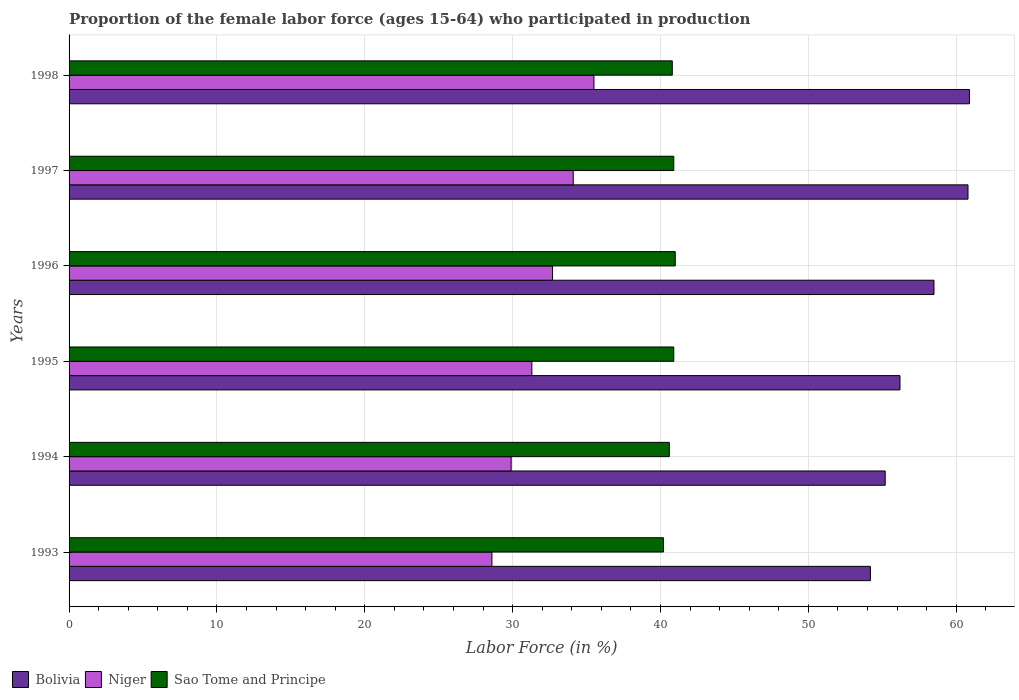Are the number of bars per tick equal to the number of legend labels?
Ensure brevity in your answer.  Yes. Are the number of bars on each tick of the Y-axis equal?
Provide a short and direct response. Yes. How many bars are there on the 2nd tick from the top?
Provide a short and direct response. 3. How many bars are there on the 4th tick from the bottom?
Give a very brief answer. 3. What is the label of the 1st group of bars from the top?
Make the answer very short. 1998. What is the proportion of the female labor force who participated in production in Sao Tome and Principe in 1998?
Make the answer very short. 40.8. Across all years, what is the maximum proportion of the female labor force who participated in production in Niger?
Offer a terse response. 35.5. Across all years, what is the minimum proportion of the female labor force who participated in production in Niger?
Provide a succinct answer. 28.6. In which year was the proportion of the female labor force who participated in production in Niger maximum?
Provide a short and direct response. 1998. What is the total proportion of the female labor force who participated in production in Sao Tome and Principe in the graph?
Your answer should be very brief. 244.4. What is the difference between the proportion of the female labor force who participated in production in Sao Tome and Principe in 1994 and that in 1996?
Keep it short and to the point. -0.4. What is the difference between the proportion of the female labor force who participated in production in Niger in 1997 and the proportion of the female labor force who participated in production in Sao Tome and Principe in 1998?
Ensure brevity in your answer.  -6.7. What is the average proportion of the female labor force who participated in production in Niger per year?
Offer a terse response. 32.02. In the year 1996, what is the difference between the proportion of the female labor force who participated in production in Sao Tome and Principe and proportion of the female labor force who participated in production in Niger?
Offer a very short reply. 8.3. What is the ratio of the proportion of the female labor force who participated in production in Sao Tome and Principe in 1993 to that in 1995?
Provide a short and direct response. 0.98. Is the difference between the proportion of the female labor force who participated in production in Sao Tome and Principe in 1993 and 1997 greater than the difference between the proportion of the female labor force who participated in production in Niger in 1993 and 1997?
Your answer should be compact. Yes. What is the difference between the highest and the second highest proportion of the female labor force who participated in production in Sao Tome and Principe?
Keep it short and to the point. 0.1. What is the difference between the highest and the lowest proportion of the female labor force who participated in production in Sao Tome and Principe?
Provide a short and direct response. 0.8. Is the sum of the proportion of the female labor force who participated in production in Sao Tome and Principe in 1994 and 1995 greater than the maximum proportion of the female labor force who participated in production in Niger across all years?
Your response must be concise. Yes. What does the 3rd bar from the bottom in 1996 represents?
Keep it short and to the point. Sao Tome and Principe. Is it the case that in every year, the sum of the proportion of the female labor force who participated in production in Sao Tome and Principe and proportion of the female labor force who participated in production in Niger is greater than the proportion of the female labor force who participated in production in Bolivia?
Your answer should be compact. Yes. How many years are there in the graph?
Your answer should be very brief. 6. What is the difference between two consecutive major ticks on the X-axis?
Ensure brevity in your answer.  10. Does the graph contain any zero values?
Your answer should be very brief. No. Does the graph contain grids?
Keep it short and to the point. Yes. How many legend labels are there?
Ensure brevity in your answer.  3. What is the title of the graph?
Keep it short and to the point. Proportion of the female labor force (ages 15-64) who participated in production. What is the label or title of the X-axis?
Keep it short and to the point. Labor Force (in %). What is the Labor Force (in %) in Bolivia in 1993?
Provide a short and direct response. 54.2. What is the Labor Force (in %) in Niger in 1993?
Keep it short and to the point. 28.6. What is the Labor Force (in %) of Sao Tome and Principe in 1993?
Give a very brief answer. 40.2. What is the Labor Force (in %) of Bolivia in 1994?
Your answer should be compact. 55.2. What is the Labor Force (in %) of Niger in 1994?
Give a very brief answer. 29.9. What is the Labor Force (in %) of Sao Tome and Principe in 1994?
Ensure brevity in your answer.  40.6. What is the Labor Force (in %) in Bolivia in 1995?
Ensure brevity in your answer.  56.2. What is the Labor Force (in %) of Niger in 1995?
Ensure brevity in your answer.  31.3. What is the Labor Force (in %) of Sao Tome and Principe in 1995?
Provide a succinct answer. 40.9. What is the Labor Force (in %) of Bolivia in 1996?
Offer a very short reply. 58.5. What is the Labor Force (in %) of Niger in 1996?
Provide a succinct answer. 32.7. What is the Labor Force (in %) in Sao Tome and Principe in 1996?
Provide a succinct answer. 41. What is the Labor Force (in %) in Bolivia in 1997?
Your answer should be very brief. 60.8. What is the Labor Force (in %) in Niger in 1997?
Make the answer very short. 34.1. What is the Labor Force (in %) of Sao Tome and Principe in 1997?
Ensure brevity in your answer.  40.9. What is the Labor Force (in %) of Bolivia in 1998?
Your answer should be very brief. 60.9. What is the Labor Force (in %) of Niger in 1998?
Give a very brief answer. 35.5. What is the Labor Force (in %) in Sao Tome and Principe in 1998?
Keep it short and to the point. 40.8. Across all years, what is the maximum Labor Force (in %) in Bolivia?
Make the answer very short. 60.9. Across all years, what is the maximum Labor Force (in %) of Niger?
Your answer should be very brief. 35.5. Across all years, what is the minimum Labor Force (in %) in Bolivia?
Keep it short and to the point. 54.2. Across all years, what is the minimum Labor Force (in %) in Niger?
Your response must be concise. 28.6. Across all years, what is the minimum Labor Force (in %) of Sao Tome and Principe?
Offer a very short reply. 40.2. What is the total Labor Force (in %) in Bolivia in the graph?
Offer a terse response. 345.8. What is the total Labor Force (in %) of Niger in the graph?
Your answer should be very brief. 192.1. What is the total Labor Force (in %) in Sao Tome and Principe in the graph?
Make the answer very short. 244.4. What is the difference between the Labor Force (in %) in Niger in 1993 and that in 1994?
Your answer should be compact. -1.3. What is the difference between the Labor Force (in %) of Bolivia in 1993 and that in 1995?
Provide a short and direct response. -2. What is the difference between the Labor Force (in %) of Sao Tome and Principe in 1993 and that in 1995?
Your response must be concise. -0.7. What is the difference between the Labor Force (in %) of Bolivia in 1993 and that in 1996?
Provide a short and direct response. -4.3. What is the difference between the Labor Force (in %) of Niger in 1993 and that in 1996?
Ensure brevity in your answer.  -4.1. What is the difference between the Labor Force (in %) of Sao Tome and Principe in 1993 and that in 1996?
Your response must be concise. -0.8. What is the difference between the Labor Force (in %) of Bolivia in 1993 and that in 1997?
Keep it short and to the point. -6.6. What is the difference between the Labor Force (in %) in Niger in 1993 and that in 1997?
Give a very brief answer. -5.5. What is the difference between the Labor Force (in %) in Sao Tome and Principe in 1993 and that in 1997?
Give a very brief answer. -0.7. What is the difference between the Labor Force (in %) in Bolivia in 1993 and that in 1998?
Your answer should be very brief. -6.7. What is the difference between the Labor Force (in %) of Niger in 1994 and that in 1995?
Keep it short and to the point. -1.4. What is the difference between the Labor Force (in %) of Sao Tome and Principe in 1994 and that in 1995?
Your answer should be compact. -0.3. What is the difference between the Labor Force (in %) in Bolivia in 1994 and that in 1996?
Your answer should be very brief. -3.3. What is the difference between the Labor Force (in %) in Niger in 1994 and that in 1996?
Provide a succinct answer. -2.8. What is the difference between the Labor Force (in %) of Bolivia in 1994 and that in 1997?
Your response must be concise. -5.6. What is the difference between the Labor Force (in %) in Sao Tome and Principe in 1994 and that in 1997?
Ensure brevity in your answer.  -0.3. What is the difference between the Labor Force (in %) of Bolivia in 1994 and that in 1998?
Your answer should be very brief. -5.7. What is the difference between the Labor Force (in %) in Sao Tome and Principe in 1994 and that in 1998?
Keep it short and to the point. -0.2. What is the difference between the Labor Force (in %) in Niger in 1995 and that in 1997?
Provide a succinct answer. -2.8. What is the difference between the Labor Force (in %) in Sao Tome and Principe in 1995 and that in 1998?
Offer a very short reply. 0.1. What is the difference between the Labor Force (in %) of Bolivia in 1996 and that in 1997?
Give a very brief answer. -2.3. What is the difference between the Labor Force (in %) of Niger in 1996 and that in 1997?
Ensure brevity in your answer.  -1.4. What is the difference between the Labor Force (in %) in Sao Tome and Principe in 1996 and that in 1997?
Provide a succinct answer. 0.1. What is the difference between the Labor Force (in %) in Sao Tome and Principe in 1996 and that in 1998?
Provide a short and direct response. 0.2. What is the difference between the Labor Force (in %) in Bolivia in 1997 and that in 1998?
Offer a terse response. -0.1. What is the difference between the Labor Force (in %) of Sao Tome and Principe in 1997 and that in 1998?
Provide a short and direct response. 0.1. What is the difference between the Labor Force (in %) in Bolivia in 1993 and the Labor Force (in %) in Niger in 1994?
Offer a very short reply. 24.3. What is the difference between the Labor Force (in %) of Bolivia in 1993 and the Labor Force (in %) of Sao Tome and Principe in 1994?
Make the answer very short. 13.6. What is the difference between the Labor Force (in %) of Niger in 1993 and the Labor Force (in %) of Sao Tome and Principe in 1994?
Your response must be concise. -12. What is the difference between the Labor Force (in %) in Bolivia in 1993 and the Labor Force (in %) in Niger in 1995?
Ensure brevity in your answer.  22.9. What is the difference between the Labor Force (in %) of Niger in 1993 and the Labor Force (in %) of Sao Tome and Principe in 1995?
Offer a terse response. -12.3. What is the difference between the Labor Force (in %) in Bolivia in 1993 and the Labor Force (in %) in Niger in 1996?
Your response must be concise. 21.5. What is the difference between the Labor Force (in %) of Niger in 1993 and the Labor Force (in %) of Sao Tome and Principe in 1996?
Keep it short and to the point. -12.4. What is the difference between the Labor Force (in %) in Bolivia in 1993 and the Labor Force (in %) in Niger in 1997?
Offer a terse response. 20.1. What is the difference between the Labor Force (in %) in Bolivia in 1994 and the Labor Force (in %) in Niger in 1995?
Ensure brevity in your answer.  23.9. What is the difference between the Labor Force (in %) of Bolivia in 1994 and the Labor Force (in %) of Sao Tome and Principe in 1995?
Make the answer very short. 14.3. What is the difference between the Labor Force (in %) of Bolivia in 1994 and the Labor Force (in %) of Niger in 1996?
Provide a short and direct response. 22.5. What is the difference between the Labor Force (in %) of Niger in 1994 and the Labor Force (in %) of Sao Tome and Principe in 1996?
Make the answer very short. -11.1. What is the difference between the Labor Force (in %) in Bolivia in 1994 and the Labor Force (in %) in Niger in 1997?
Make the answer very short. 21.1. What is the difference between the Labor Force (in %) in Bolivia in 1994 and the Labor Force (in %) in Sao Tome and Principe in 1997?
Give a very brief answer. 14.3. What is the difference between the Labor Force (in %) of Bolivia in 1995 and the Labor Force (in %) of Niger in 1996?
Keep it short and to the point. 23.5. What is the difference between the Labor Force (in %) in Bolivia in 1995 and the Labor Force (in %) in Niger in 1997?
Your answer should be very brief. 22.1. What is the difference between the Labor Force (in %) of Bolivia in 1995 and the Labor Force (in %) of Sao Tome and Principe in 1997?
Your answer should be very brief. 15.3. What is the difference between the Labor Force (in %) in Bolivia in 1995 and the Labor Force (in %) in Niger in 1998?
Offer a terse response. 20.7. What is the difference between the Labor Force (in %) of Bolivia in 1996 and the Labor Force (in %) of Niger in 1997?
Provide a succinct answer. 24.4. What is the difference between the Labor Force (in %) of Bolivia in 1996 and the Labor Force (in %) of Sao Tome and Principe in 1998?
Provide a succinct answer. 17.7. What is the difference between the Labor Force (in %) in Bolivia in 1997 and the Labor Force (in %) in Niger in 1998?
Keep it short and to the point. 25.3. What is the difference between the Labor Force (in %) of Niger in 1997 and the Labor Force (in %) of Sao Tome and Principe in 1998?
Provide a short and direct response. -6.7. What is the average Labor Force (in %) in Bolivia per year?
Provide a short and direct response. 57.63. What is the average Labor Force (in %) of Niger per year?
Offer a very short reply. 32.02. What is the average Labor Force (in %) in Sao Tome and Principe per year?
Keep it short and to the point. 40.73. In the year 1993, what is the difference between the Labor Force (in %) in Bolivia and Labor Force (in %) in Niger?
Offer a terse response. 25.6. In the year 1993, what is the difference between the Labor Force (in %) in Bolivia and Labor Force (in %) in Sao Tome and Principe?
Provide a short and direct response. 14. In the year 1994, what is the difference between the Labor Force (in %) in Bolivia and Labor Force (in %) in Niger?
Provide a succinct answer. 25.3. In the year 1995, what is the difference between the Labor Force (in %) of Bolivia and Labor Force (in %) of Niger?
Make the answer very short. 24.9. In the year 1995, what is the difference between the Labor Force (in %) in Niger and Labor Force (in %) in Sao Tome and Principe?
Make the answer very short. -9.6. In the year 1996, what is the difference between the Labor Force (in %) of Bolivia and Labor Force (in %) of Niger?
Offer a very short reply. 25.8. In the year 1996, what is the difference between the Labor Force (in %) in Bolivia and Labor Force (in %) in Sao Tome and Principe?
Keep it short and to the point. 17.5. In the year 1996, what is the difference between the Labor Force (in %) in Niger and Labor Force (in %) in Sao Tome and Principe?
Make the answer very short. -8.3. In the year 1997, what is the difference between the Labor Force (in %) of Bolivia and Labor Force (in %) of Niger?
Your answer should be compact. 26.7. In the year 1997, what is the difference between the Labor Force (in %) in Bolivia and Labor Force (in %) in Sao Tome and Principe?
Your answer should be compact. 19.9. In the year 1998, what is the difference between the Labor Force (in %) in Bolivia and Labor Force (in %) in Niger?
Make the answer very short. 25.4. In the year 1998, what is the difference between the Labor Force (in %) in Bolivia and Labor Force (in %) in Sao Tome and Principe?
Your answer should be compact. 20.1. What is the ratio of the Labor Force (in %) of Bolivia in 1993 to that in 1994?
Offer a terse response. 0.98. What is the ratio of the Labor Force (in %) of Niger in 1993 to that in 1994?
Keep it short and to the point. 0.96. What is the ratio of the Labor Force (in %) of Sao Tome and Principe in 1993 to that in 1994?
Give a very brief answer. 0.99. What is the ratio of the Labor Force (in %) of Bolivia in 1993 to that in 1995?
Make the answer very short. 0.96. What is the ratio of the Labor Force (in %) in Niger in 1993 to that in 1995?
Your answer should be very brief. 0.91. What is the ratio of the Labor Force (in %) in Sao Tome and Principe in 1993 to that in 1995?
Provide a short and direct response. 0.98. What is the ratio of the Labor Force (in %) of Bolivia in 1993 to that in 1996?
Make the answer very short. 0.93. What is the ratio of the Labor Force (in %) in Niger in 1993 to that in 1996?
Ensure brevity in your answer.  0.87. What is the ratio of the Labor Force (in %) of Sao Tome and Principe in 1993 to that in 1996?
Your response must be concise. 0.98. What is the ratio of the Labor Force (in %) in Bolivia in 1993 to that in 1997?
Your answer should be very brief. 0.89. What is the ratio of the Labor Force (in %) of Niger in 1993 to that in 1997?
Keep it short and to the point. 0.84. What is the ratio of the Labor Force (in %) of Sao Tome and Principe in 1993 to that in 1997?
Provide a succinct answer. 0.98. What is the ratio of the Labor Force (in %) of Bolivia in 1993 to that in 1998?
Provide a succinct answer. 0.89. What is the ratio of the Labor Force (in %) of Niger in 1993 to that in 1998?
Offer a very short reply. 0.81. What is the ratio of the Labor Force (in %) of Bolivia in 1994 to that in 1995?
Give a very brief answer. 0.98. What is the ratio of the Labor Force (in %) of Niger in 1994 to that in 1995?
Provide a succinct answer. 0.96. What is the ratio of the Labor Force (in %) in Sao Tome and Principe in 1994 to that in 1995?
Offer a terse response. 0.99. What is the ratio of the Labor Force (in %) of Bolivia in 1994 to that in 1996?
Your answer should be very brief. 0.94. What is the ratio of the Labor Force (in %) of Niger in 1994 to that in 1996?
Make the answer very short. 0.91. What is the ratio of the Labor Force (in %) of Sao Tome and Principe in 1994 to that in 1996?
Make the answer very short. 0.99. What is the ratio of the Labor Force (in %) in Bolivia in 1994 to that in 1997?
Offer a terse response. 0.91. What is the ratio of the Labor Force (in %) of Niger in 1994 to that in 1997?
Offer a very short reply. 0.88. What is the ratio of the Labor Force (in %) of Bolivia in 1994 to that in 1998?
Give a very brief answer. 0.91. What is the ratio of the Labor Force (in %) in Niger in 1994 to that in 1998?
Provide a succinct answer. 0.84. What is the ratio of the Labor Force (in %) in Sao Tome and Principe in 1994 to that in 1998?
Offer a terse response. 1. What is the ratio of the Labor Force (in %) in Bolivia in 1995 to that in 1996?
Offer a very short reply. 0.96. What is the ratio of the Labor Force (in %) of Niger in 1995 to that in 1996?
Provide a succinct answer. 0.96. What is the ratio of the Labor Force (in %) in Bolivia in 1995 to that in 1997?
Offer a terse response. 0.92. What is the ratio of the Labor Force (in %) of Niger in 1995 to that in 1997?
Offer a terse response. 0.92. What is the ratio of the Labor Force (in %) of Sao Tome and Principe in 1995 to that in 1997?
Your answer should be very brief. 1. What is the ratio of the Labor Force (in %) of Bolivia in 1995 to that in 1998?
Your answer should be very brief. 0.92. What is the ratio of the Labor Force (in %) in Niger in 1995 to that in 1998?
Give a very brief answer. 0.88. What is the ratio of the Labor Force (in %) of Bolivia in 1996 to that in 1997?
Your answer should be very brief. 0.96. What is the ratio of the Labor Force (in %) in Niger in 1996 to that in 1997?
Your answer should be very brief. 0.96. What is the ratio of the Labor Force (in %) of Sao Tome and Principe in 1996 to that in 1997?
Your response must be concise. 1. What is the ratio of the Labor Force (in %) in Bolivia in 1996 to that in 1998?
Your response must be concise. 0.96. What is the ratio of the Labor Force (in %) of Niger in 1996 to that in 1998?
Ensure brevity in your answer.  0.92. What is the ratio of the Labor Force (in %) of Niger in 1997 to that in 1998?
Provide a succinct answer. 0.96. What is the ratio of the Labor Force (in %) in Sao Tome and Principe in 1997 to that in 1998?
Make the answer very short. 1. What is the difference between the highest and the second highest Labor Force (in %) in Bolivia?
Offer a very short reply. 0.1. What is the difference between the highest and the second highest Labor Force (in %) of Niger?
Your answer should be very brief. 1.4. What is the difference between the highest and the second highest Labor Force (in %) in Sao Tome and Principe?
Provide a short and direct response. 0.1. What is the difference between the highest and the lowest Labor Force (in %) in Bolivia?
Your response must be concise. 6.7. What is the difference between the highest and the lowest Labor Force (in %) of Niger?
Your answer should be very brief. 6.9. 